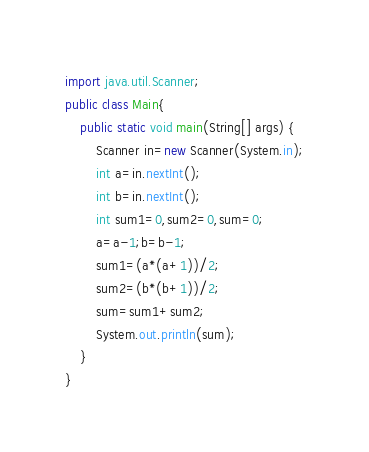<code> <loc_0><loc_0><loc_500><loc_500><_Java_>import java.util.Scanner;
public class Main{
    public static void main(String[] args) {
        Scanner in=new Scanner(System.in);
        int a=in.nextInt();
        int b=in.nextInt();
        int sum1=0,sum2=0,sum=0;
        a=a-1;b=b-1;
        sum1=(a*(a+1))/2;
        sum2=(b*(b+1))/2;
        sum=sum1+sum2;
        System.out.println(sum);
    }
}</code> 